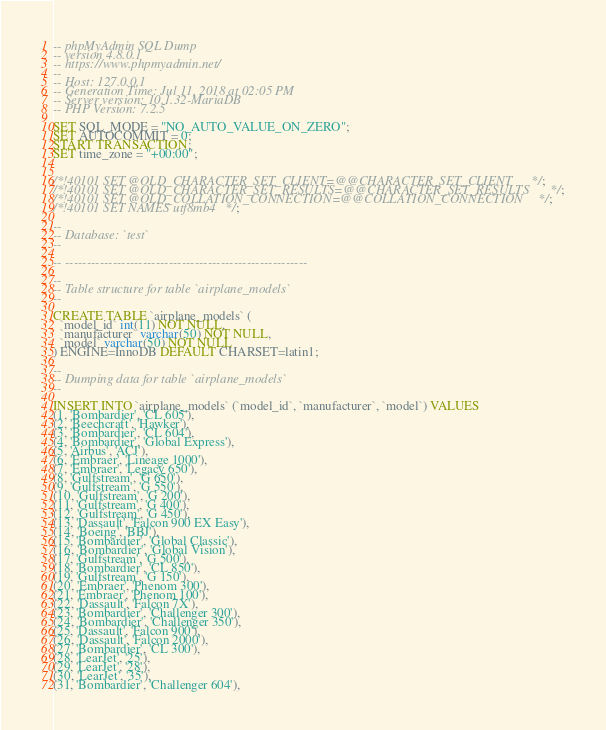<code> <loc_0><loc_0><loc_500><loc_500><_SQL_>-- phpMyAdmin SQL Dump
-- version 4.8.0.1
-- https://www.phpmyadmin.net/
--
-- Host: 127.0.0.1
-- Generation Time: Jul 11, 2018 at 02:05 PM
-- Server version: 10.1.32-MariaDB
-- PHP Version: 7.2.5

SET SQL_MODE = "NO_AUTO_VALUE_ON_ZERO";
SET AUTOCOMMIT = 0;
START TRANSACTION;
SET time_zone = "+00:00";


/*!40101 SET @OLD_CHARACTER_SET_CLIENT=@@CHARACTER_SET_CLIENT */;
/*!40101 SET @OLD_CHARACTER_SET_RESULTS=@@CHARACTER_SET_RESULTS */;
/*!40101 SET @OLD_COLLATION_CONNECTION=@@COLLATION_CONNECTION */;
/*!40101 SET NAMES utf8mb4 */;

--
-- Database: `test`
--

-- --------------------------------------------------------

--
-- Table structure for table `airplane_models`
--

CREATE TABLE `airplane_models` (
  `model_id` int(11) NOT NULL,
  `manufacturer` varchar(50) NOT NULL,
  `model` varchar(50) NOT NULL
) ENGINE=InnoDB DEFAULT CHARSET=latin1;

--
-- Dumping data for table `airplane_models`
--

INSERT INTO `airplane_models` (`model_id`, `manufacturer`, `model`) VALUES
(1, 'Bombardier', 'CL 605'),
(2, 'Beechcraft', 'Hawker'),
(3, 'Bombardier', 'CL 604'),
(4, 'Bombardier', 'Global Express'),
(5, 'Airbus', 'ACJ'),
(6, 'Embraer', 'Lineage 1000'),
(7, 'Embraer', 'Legacy 650'),
(8, 'Gulfstream', 'G 650'),
(9, 'Gulfstream', 'G 550'),
(10, 'Gulfstream', 'G 200'),
(11, 'Gulfstream', 'G 400'),
(12, 'Gulfstream', 'G 450'),
(13, 'Dassault', 'Falcon 900 EX Easy'),
(14, 'Boeing', 'BBJ'),
(15, 'Bombardier', 'Global Classic'),
(16, 'Bombardier', 'Global Vision'),
(17, 'Gulfstream', 'G 500'),
(18, 'Bombardier', 'CL 850'),
(19, 'Gulfstream', 'G 150'),
(20, 'Embraer', 'Phenom 300'),
(21, 'Embraer', 'Phenom 100'),
(22, 'Dassault', 'Falcon 7X'),
(23, 'Bombardier', 'Challenger 300'),
(24, 'Bombardier', 'Challenger 350'),
(25, 'Dassault', 'Falcon 900'),
(26, 'Dassault', 'Falcon 2000'),
(27, 'Bombardier', 'CL 300'),
(28, 'LearJet', '25'),
(29, 'LearJet', '28'),
(30, 'LearJet', '35'),
(31, 'Bombardier', 'Challenger 604'),</code> 